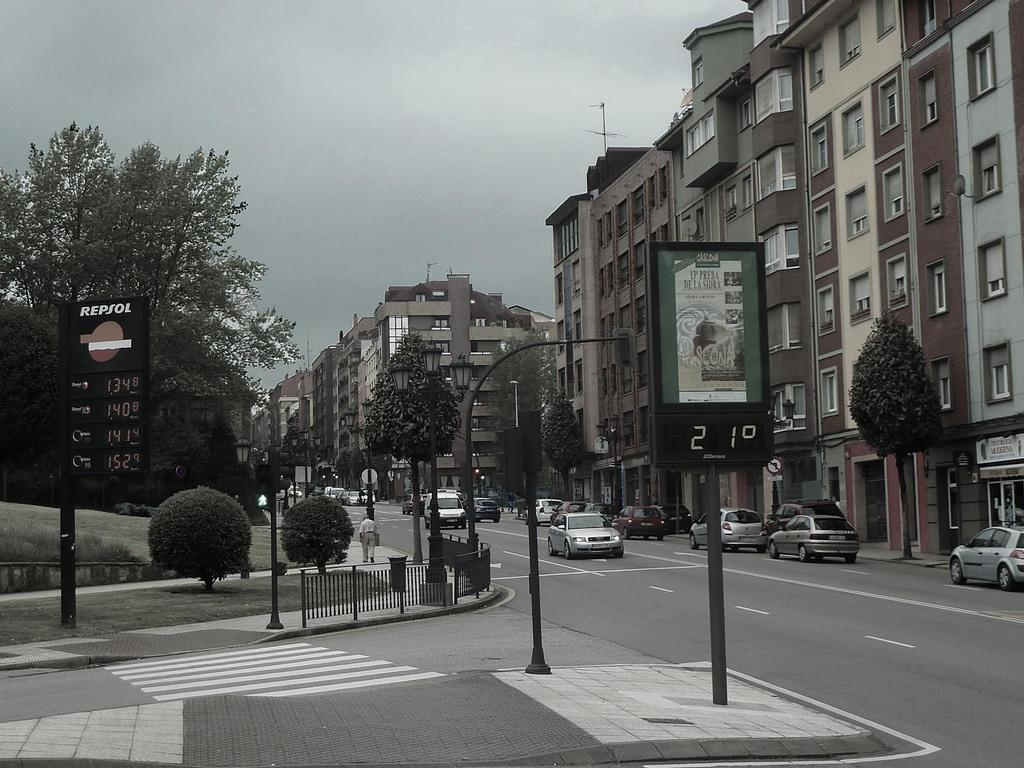<image>
Describe the image concisely. a street scene with signs for Repsol cost of 1.348 